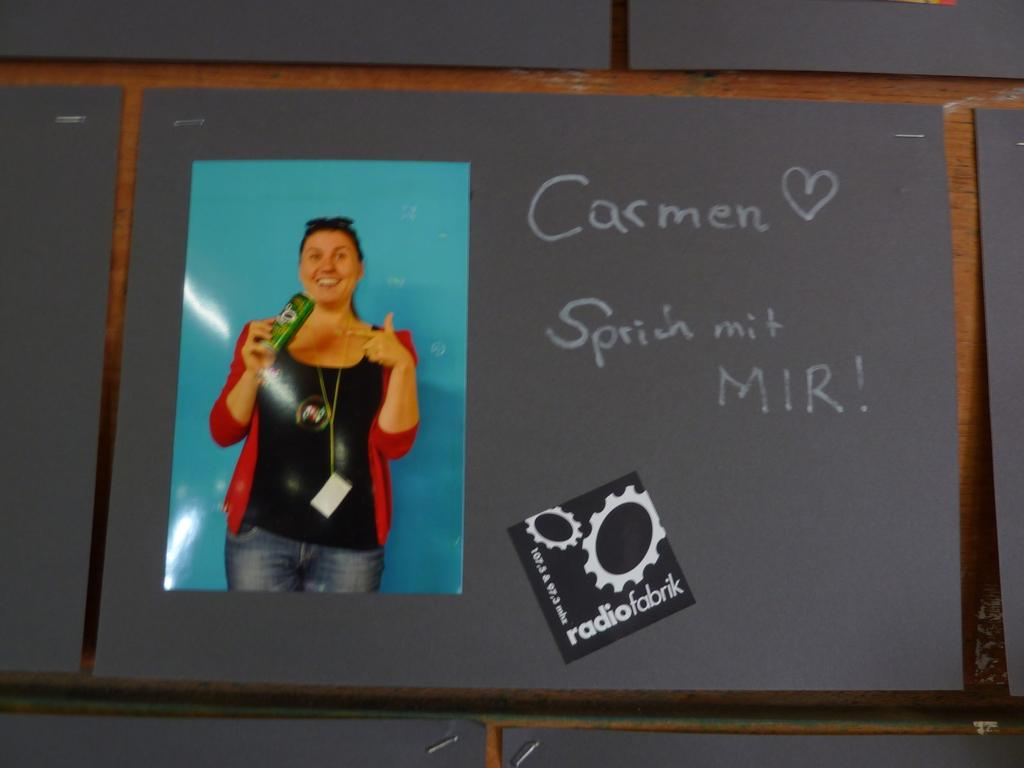What is the main object in the image? There is a board in the image. What can be seen on the board? Something is written on the board, and there is a picture of a lady on it. Can you describe the lady in the picture? The lady in the picture is wearing a tag and holding something in her hand. How many fish are swimming around the furniture in the image? There are no fish or furniture present in the image; it features a board with a picture of a lady. What type of arch can be seen in the image? There is no arch present in the image. 